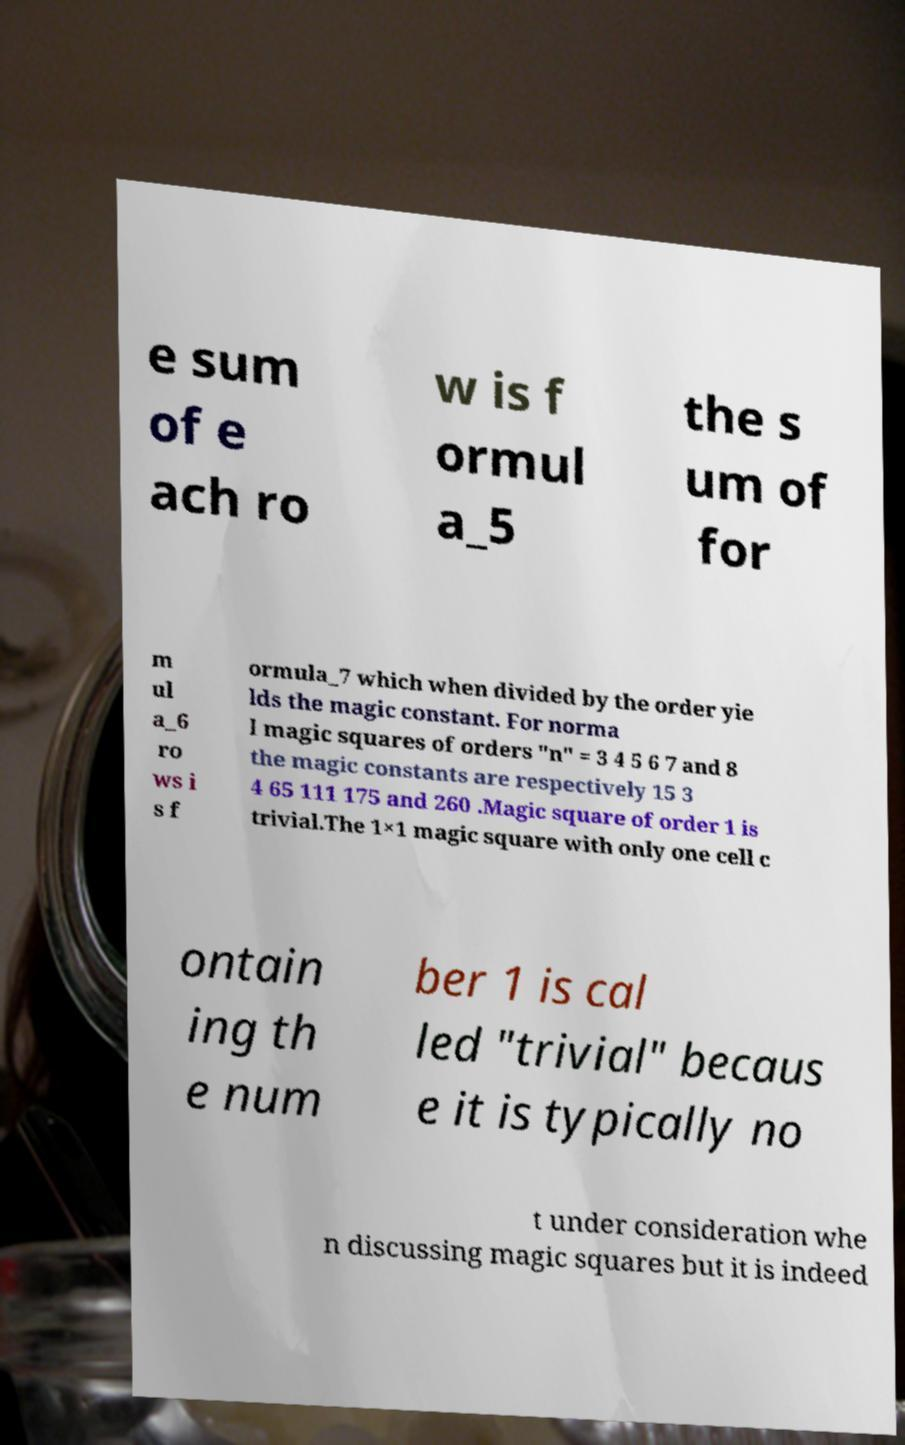I need the written content from this picture converted into text. Can you do that? e sum of e ach ro w is f ormul a_5 the s um of for m ul a_6 ro ws i s f ormula_7 which when divided by the order yie lds the magic constant. For norma l magic squares of orders "n" = 3 4 5 6 7 and 8 the magic constants are respectively 15 3 4 65 111 175 and 260 .Magic square of order 1 is trivial.The 1×1 magic square with only one cell c ontain ing th e num ber 1 is cal led "trivial" becaus e it is typically no t under consideration whe n discussing magic squares but it is indeed 